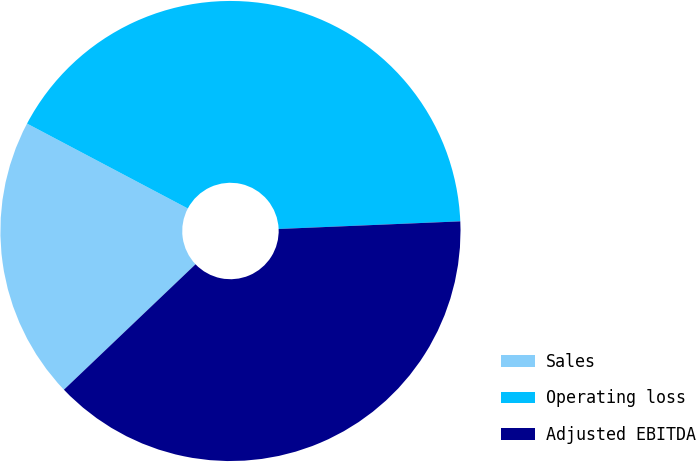Convert chart. <chart><loc_0><loc_0><loc_500><loc_500><pie_chart><fcel>Sales<fcel>Operating loss<fcel>Adjusted EBITDA<nl><fcel>19.85%<fcel>41.6%<fcel>38.55%<nl></chart> 